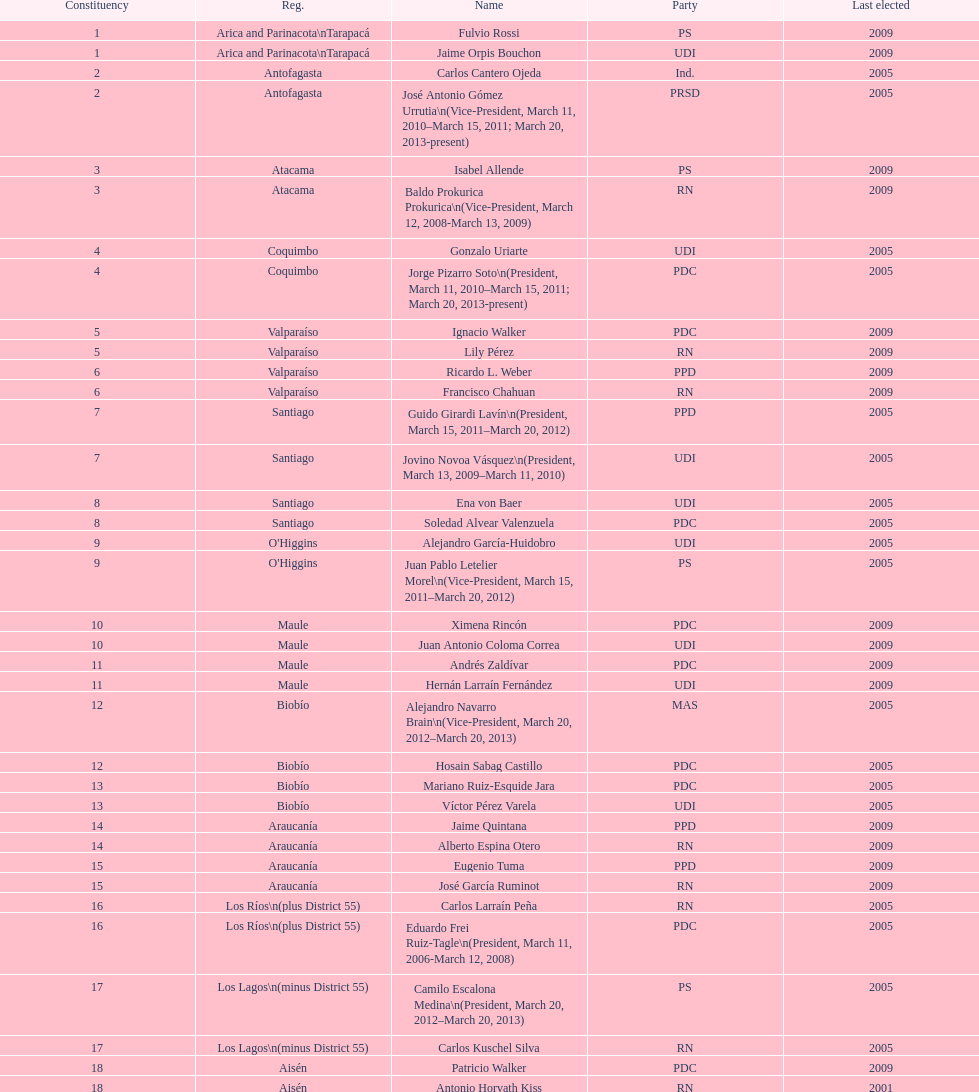What is the first name on the table? Fulvio Rossi. Could you help me parse every detail presented in this table? {'header': ['Constituency', 'Reg.', 'Name', 'Party', 'Last elected'], 'rows': [['1', 'Arica and Parinacota\\nTarapacá', 'Fulvio Rossi', 'PS', '2009'], ['1', 'Arica and Parinacota\\nTarapacá', 'Jaime Orpis Bouchon', 'UDI', '2009'], ['2', 'Antofagasta', 'Carlos Cantero Ojeda', 'Ind.', '2005'], ['2', 'Antofagasta', 'José Antonio Gómez Urrutia\\n(Vice-President, March 11, 2010–March 15, 2011; March 20, 2013-present)', 'PRSD', '2005'], ['3', 'Atacama', 'Isabel Allende', 'PS', '2009'], ['3', 'Atacama', 'Baldo Prokurica Prokurica\\n(Vice-President, March 12, 2008-March 13, 2009)', 'RN', '2009'], ['4', 'Coquimbo', 'Gonzalo Uriarte', 'UDI', '2005'], ['4', 'Coquimbo', 'Jorge Pizarro Soto\\n(President, March 11, 2010–March 15, 2011; March 20, 2013-present)', 'PDC', '2005'], ['5', 'Valparaíso', 'Ignacio Walker', 'PDC', '2009'], ['5', 'Valparaíso', 'Lily Pérez', 'RN', '2009'], ['6', 'Valparaíso', 'Ricardo L. Weber', 'PPD', '2009'], ['6', 'Valparaíso', 'Francisco Chahuan', 'RN', '2009'], ['7', 'Santiago', 'Guido Girardi Lavín\\n(President, March 15, 2011–March 20, 2012)', 'PPD', '2005'], ['7', 'Santiago', 'Jovino Novoa Vásquez\\n(President, March 13, 2009–March 11, 2010)', 'UDI', '2005'], ['8', 'Santiago', 'Ena von Baer', 'UDI', '2005'], ['8', 'Santiago', 'Soledad Alvear Valenzuela', 'PDC', '2005'], ['9', "O'Higgins", 'Alejandro García-Huidobro', 'UDI', '2005'], ['9', "O'Higgins", 'Juan Pablo Letelier Morel\\n(Vice-President, March 15, 2011–March 20, 2012)', 'PS', '2005'], ['10', 'Maule', 'Ximena Rincón', 'PDC', '2009'], ['10', 'Maule', 'Juan Antonio Coloma Correa', 'UDI', '2009'], ['11', 'Maule', 'Andrés Zaldívar', 'PDC', '2009'], ['11', 'Maule', 'Hernán Larraín Fernández', 'UDI', '2009'], ['12', 'Biobío', 'Alejandro Navarro Brain\\n(Vice-President, March 20, 2012–March 20, 2013)', 'MAS', '2005'], ['12', 'Biobío', 'Hosain Sabag Castillo', 'PDC', '2005'], ['13', 'Biobío', 'Mariano Ruiz-Esquide Jara', 'PDC', '2005'], ['13', 'Biobío', 'Víctor Pérez Varela', 'UDI', '2005'], ['14', 'Araucanía', 'Jaime Quintana', 'PPD', '2009'], ['14', 'Araucanía', 'Alberto Espina Otero', 'RN', '2009'], ['15', 'Araucanía', 'Eugenio Tuma', 'PPD', '2009'], ['15', 'Araucanía', 'José García Ruminot', 'RN', '2009'], ['16', 'Los Ríos\\n(plus District 55)', 'Carlos Larraín Peña', 'RN', '2005'], ['16', 'Los Ríos\\n(plus District 55)', 'Eduardo Frei Ruiz-Tagle\\n(President, March 11, 2006-March 12, 2008)', 'PDC', '2005'], ['17', 'Los Lagos\\n(minus District 55)', 'Camilo Escalona Medina\\n(President, March 20, 2012–March 20, 2013)', 'PS', '2005'], ['17', 'Los Lagos\\n(minus District 55)', 'Carlos Kuschel Silva', 'RN', '2005'], ['18', 'Aisén', 'Patricio Walker', 'PDC', '2009'], ['18', 'Aisén', 'Antonio Horvath Kiss', 'RN', '2001'], ['19', 'Magallanes', 'Carlos Bianchi Chelech\\n(Vice-President, March 13, 2009–March 11, 2010)', 'Ind.', '2005'], ['19', 'Magallanes', 'Pedro Muñoz Aburto', 'PS', '2005']]} 